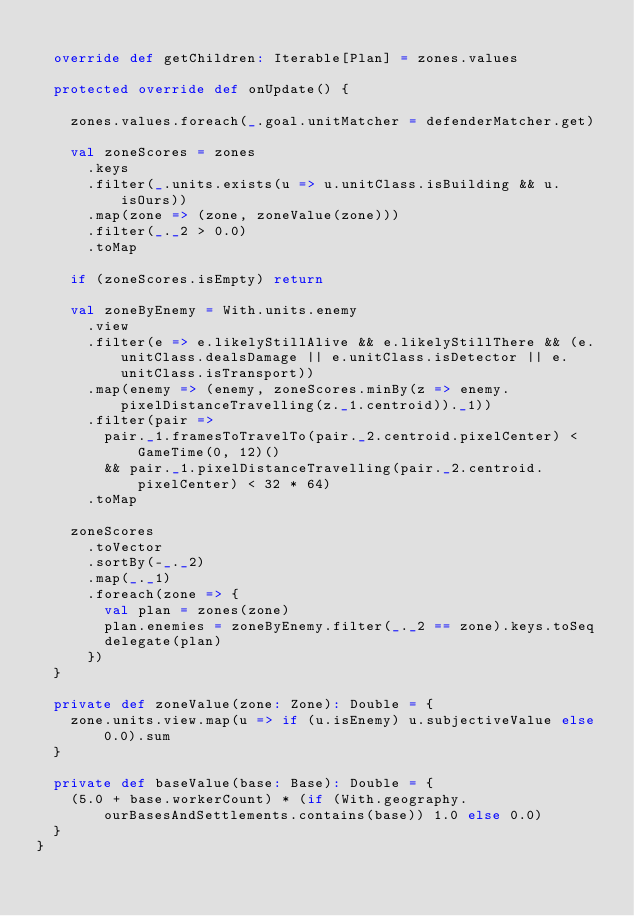<code> <loc_0><loc_0><loc_500><loc_500><_Scala_>  
  override def getChildren: Iterable[Plan] = zones.values
  
  protected override def onUpdate() {

    zones.values.foreach(_.goal.unitMatcher = defenderMatcher.get)

    val zoneScores = zones
      .keys
      .filter(_.units.exists(u => u.unitClass.isBuilding && u.isOurs))
      .map(zone => (zone, zoneValue(zone)))
      .filter(_._2 > 0.0)
      .toMap
    
    if (zoneScores.isEmpty) return
    
    val zoneByEnemy = With.units.enemy
      .view
      .filter(e => e.likelyStillAlive && e.likelyStillThere && (e.unitClass.dealsDamage || e.unitClass.isDetector || e.unitClass.isTransport))
      .map(enemy => (enemy, zoneScores.minBy(z => enemy.pixelDistanceTravelling(z._1.centroid))._1))
      .filter(pair =>
        pair._1.framesToTravelTo(pair._2.centroid.pixelCenter) < GameTime(0, 12)()
        && pair._1.pixelDistanceTravelling(pair._2.centroid.pixelCenter) < 32 * 64)
      .toMap
    
    zoneScores
      .toVector
      .sortBy(-_._2)
      .map(_._1)
      .foreach(zone => {
        val plan = zones(zone)
        plan.enemies = zoneByEnemy.filter(_._2 == zone).keys.toSeq
        delegate(plan)
      })
  }
  
  private def zoneValue(zone: Zone): Double = {
    zone.units.view.map(u => if (u.isEnemy) u.subjectiveValue else 0.0).sum
  }
  
  private def baseValue(base: Base): Double = {
    (5.0 + base.workerCount) * (if (With.geography.ourBasesAndSettlements.contains(base)) 1.0 else 0.0)
  }
}
</code> 